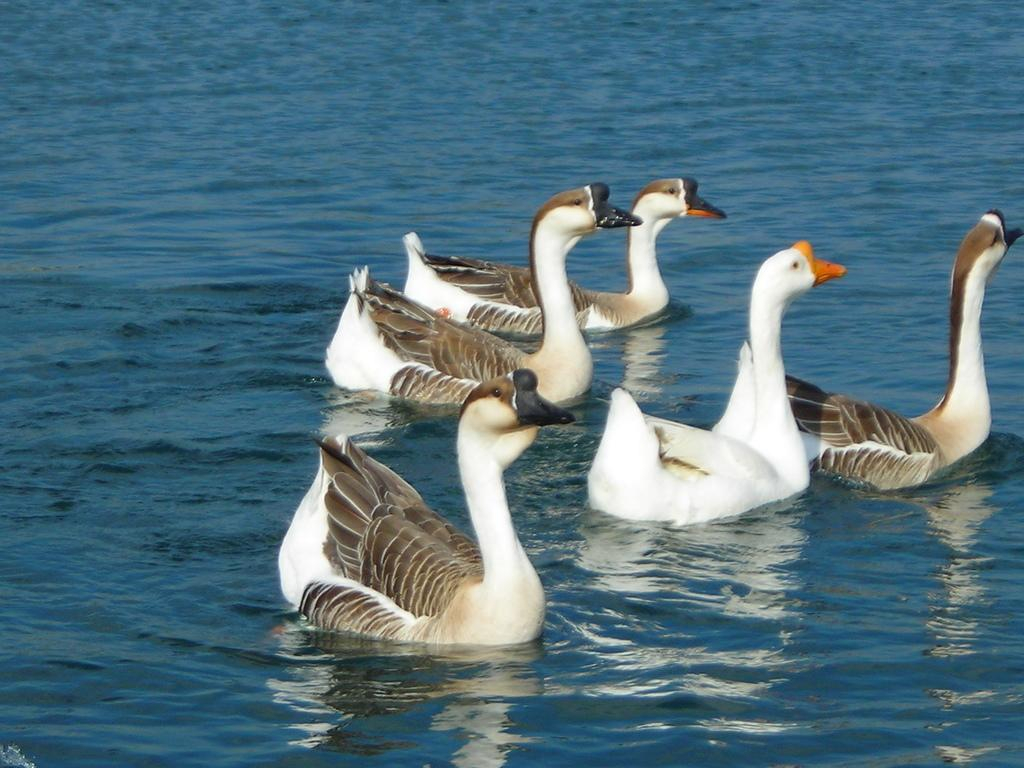What type of animals are in the image? There are ducks in the image. Where are the ducks located? The ducks are in the water. What colors can be seen on the ducks? The ducks have white and brown colors. How many mice can be seen playing with the ducks in the image? There are no mice present in the image, and therefore no such activity can be observed. 